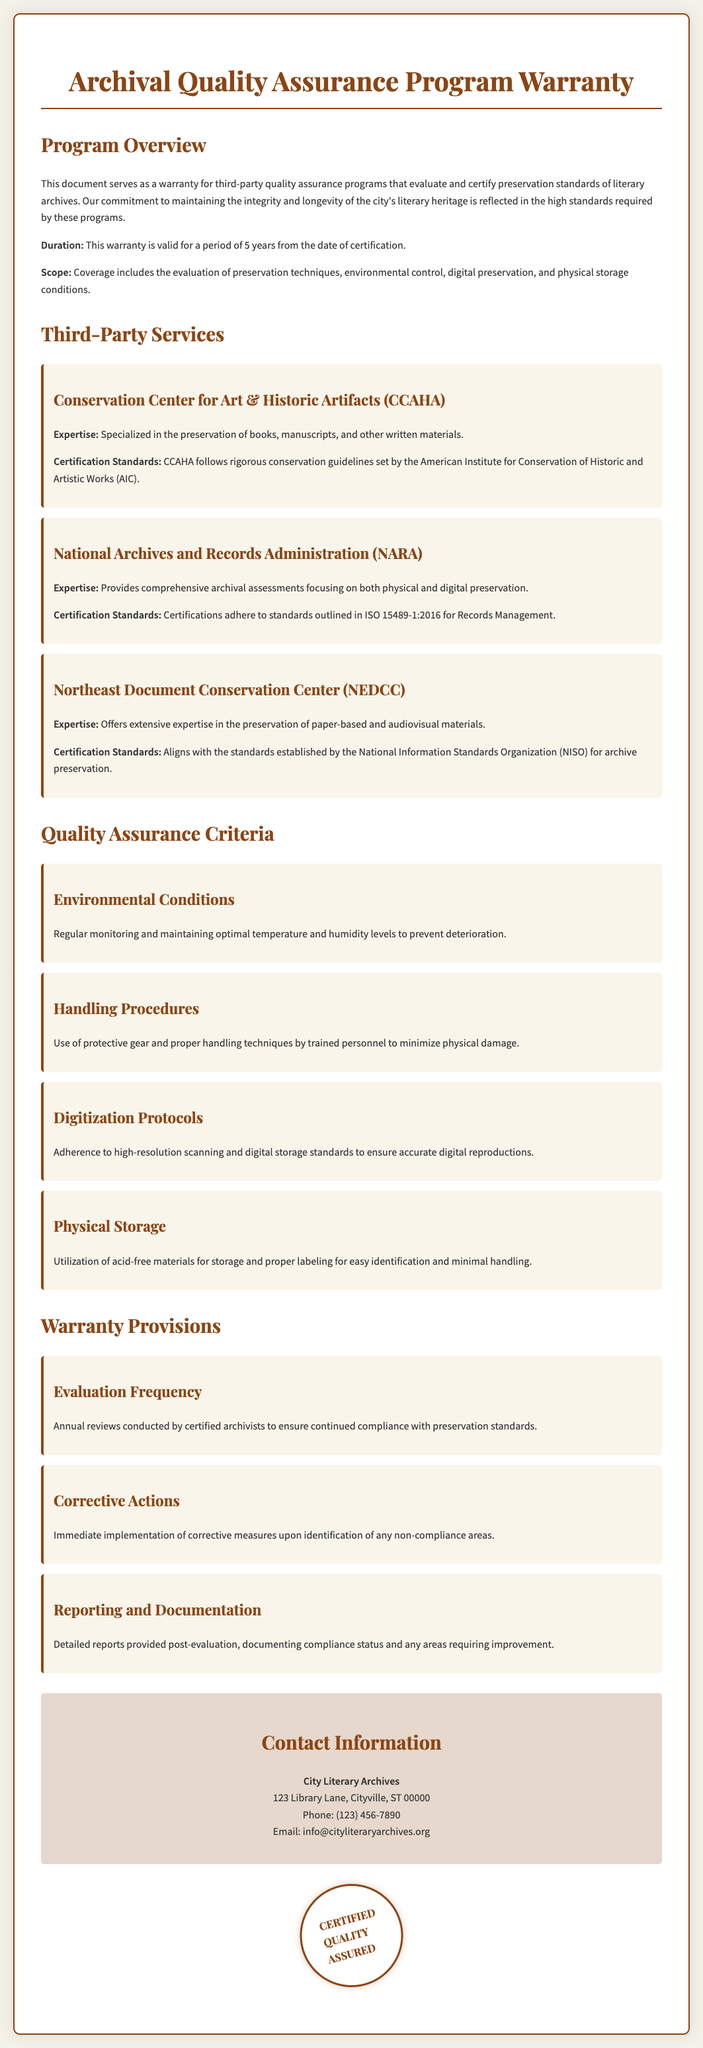What is the duration of the warranty? The duration of the warranty is specified as 5 years from the date of certification.
Answer: 5 years What is the expertise of CCAHA? CCAHA is specialized in the preservation of books, manuscripts, and other written materials.
Answer: Preservation of books, manuscripts, and other written materials Which organization follows ISO 15489-1:2016 standards? The National Archives and Records Administration (NARA) is the organization that adheres to these standards.
Answer: National Archives and Records Administration (NARA) What criteria are used to evaluate environmental conditions? The criterion for environmental conditions includes regular monitoring and maintaining optimal temperature and humidity levels.
Answer: Regular monitoring and maintaining optimal temperature and humidity levels How often are evaluations conducted according to the warranty provisions? The warranty provisions state that evaluations are conducted annually.
Answer: Annually What type of materials is specified for physical storage? The warranty specifies the utilization of acid-free materials for storage.
Answer: Acid-free materials What does the stamp on the document say? The stamp indicates certification of quality assurance.
Answer: CERTIFIED QUALITY ASSURED Who provides detailed reports after evaluations? Certified archivists are responsible for providing detailed reports post-evaluation.
Answer: Certified archivists What is the contact email for the City Literary Archives? The email provided for the City Literary Archives is displayed in the contact information section.
Answer: info@cityliteraryarchives.org 